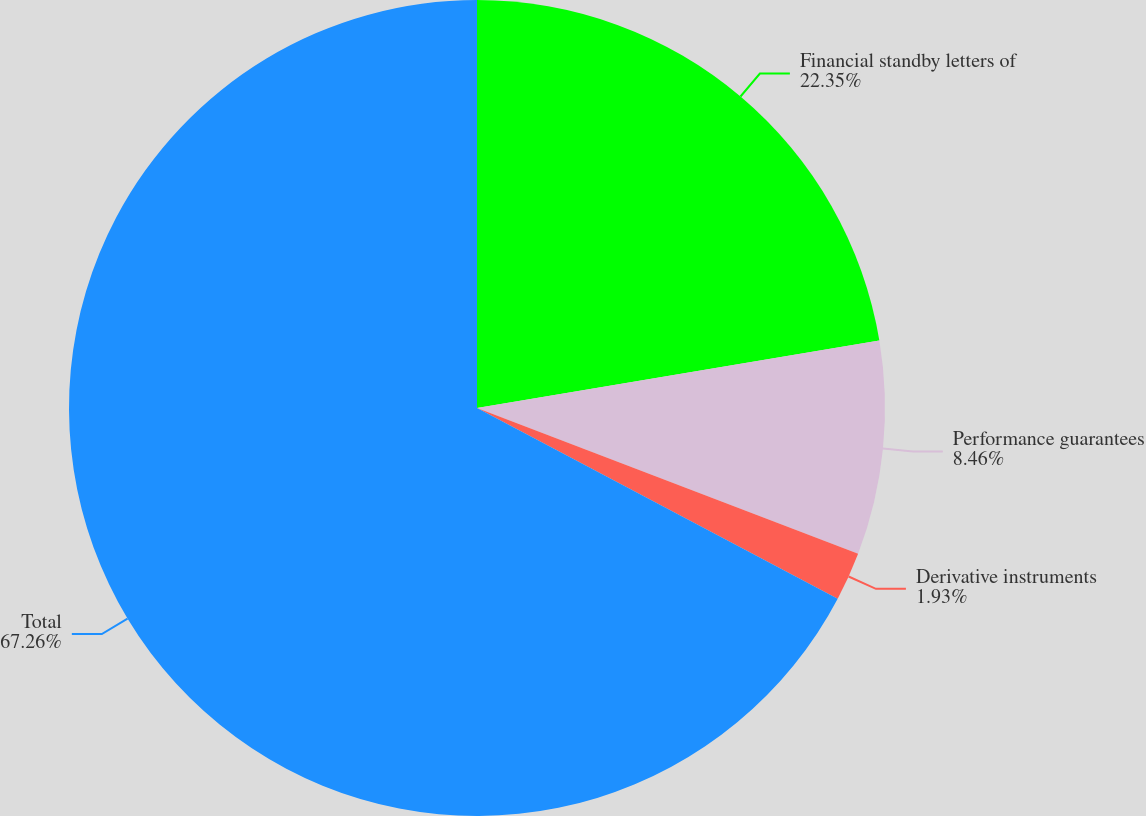<chart> <loc_0><loc_0><loc_500><loc_500><pie_chart><fcel>Financial standby letters of<fcel>Performance guarantees<fcel>Derivative instruments<fcel>Total<nl><fcel>22.35%<fcel>8.46%<fcel>1.93%<fcel>67.26%<nl></chart> 